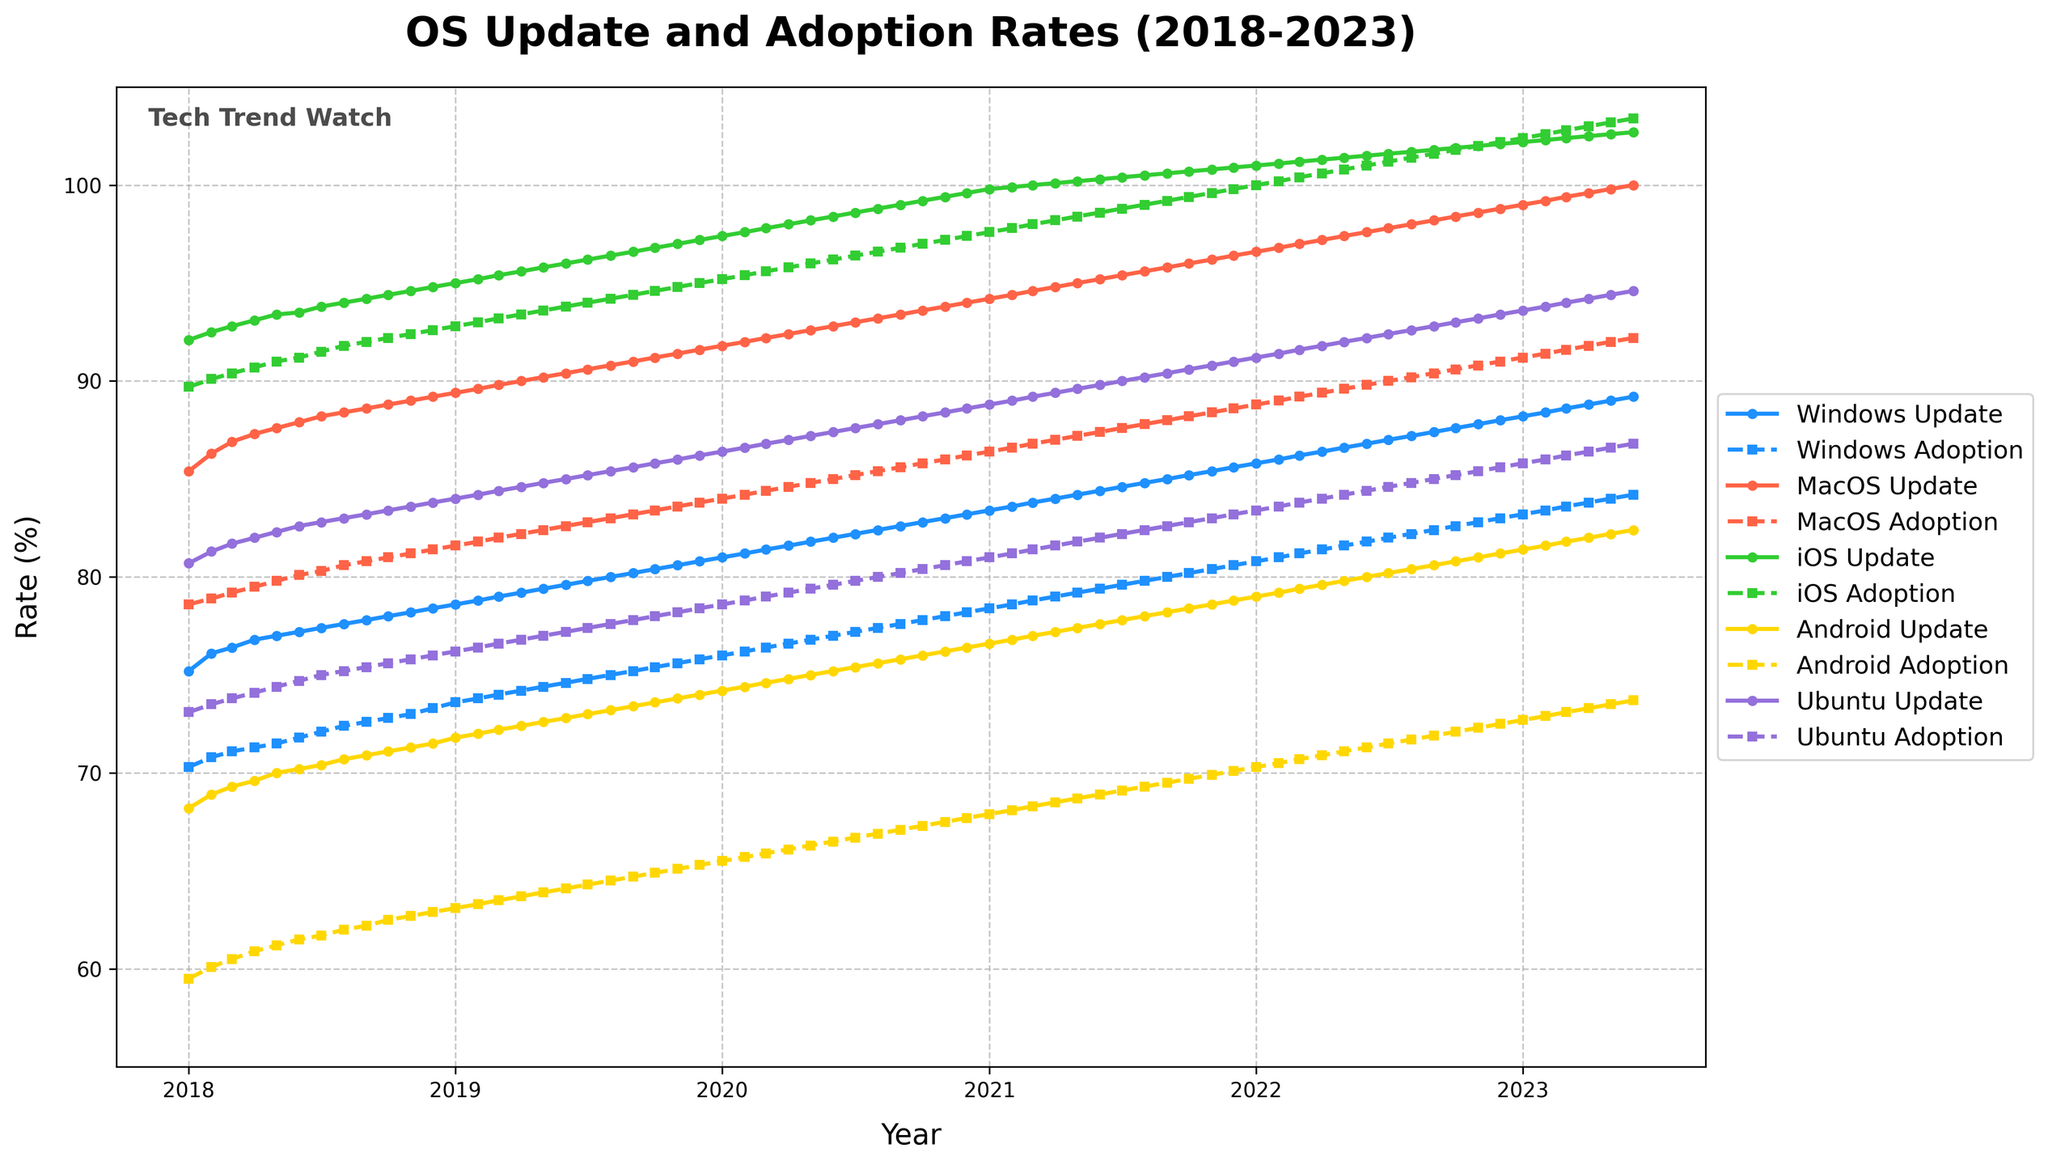What is the title of the plot? The title of the plot is clearly displayed at the top of the figure. The text reads 'OS Update and Adoption Rates (2018-2023)'.
Answer: OS Update and Adoption Rates (2018-2023) How many operating systems are tracked in the chart? The chart plots lines for five different operating systems. Each line is distinguished by a different color, and the legend on the right side of the plot lists these operating systems.
Answer: Five Which operating system has the highest update rate in January 2023? To find this, look at the data points for January 2023 and identify the highest value among the 'Update Rate' lines. Per the figure, iOS has the highest update rate.
Answer: iOS Which operating system shows the smallest difference between update rate and adoption rate throughout the period? To determine this, inspect the lines for each operating system and compare the distance between 'Update' and 'Adoption' rates. iOS consistently shows little difference between its update rate and adoption rate.
Answer: iOS Describe the trend for the Windows Adoption Rate over the period from 2018 to 2023. Observe the Windows Adoption Rate line in the plot. It shows a general upward trend from approximately 70.3% in January 2018 to 84.2% in June 2023.
Answer: Upward trend What are the adoption rates for Ubuntu and iOS in June 2023? Look at the data points for June 2023 for both Ubuntu and iOS 'Adoption Rate' lines. Ubuntu's adoption rate is approximately 86.8%, while iOS's adoption rate is roughly 103.4%.
Answer: Ubuntu: 86.8%, iOS: 103.4% Which operating system had the fastest growth in adoption rate from 2018 to 2023? Compare the slopes of the adoption rate lines for each operating system from 2018 to 2023. iOS had the fastest growth as its adoption rate increased rapidly and reached over 100%.
Answer: iOS How does the adoption rate of MacOS in January 2022 compare to the adoption rate of Windows in the same month? Check the figure for the adoption rates of MacOS and Windows in January 2022. MacOS has an adoption rate of about 88.8%, while Windows is around 80.8%.
Answer: MacOS > Windows What is the average update rate for Android in the entire period? To calculate the average update rate for Android, add up all the data points for 'Android Update Rate' and divide by the number of data points. This is a more complex calculation requiring summing all values and dividing by 66 (each month's data point from January 2018 to June 2023).
Answer: Complex exact value calculation needed 